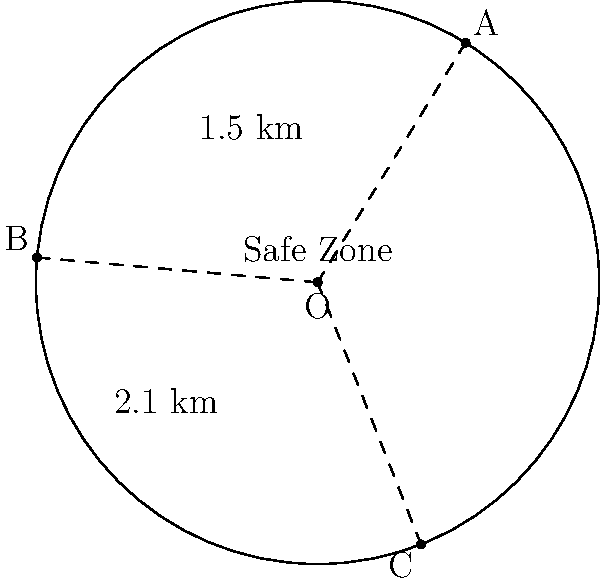A circular safe zone is established around a coal-fired power plant to minimize health risks. Three data points (A, B, and C) on the circumference of this safe zone are known. The distance between A and B is 1.5 km, and the distance between B and C is 2.1 km. What is the radius of the safe zone in kilometers? Let's solve this step-by-step:

1) In a circle, the center angle subtended by a chord is twice the inscribed angle subtended by the same chord.

2) The inscribed angle for chord AB is 45° (half of the 90° central angle AOB), and for BC is 45° (half of the 90° central angle BOC).

3) We can use the chord length formula: $chord = 2R \sin(\theta/2)$, where R is the radius and $\theta$ is the central angle.

4) For AB: $1.5 = 2R \sin(90°/2) = 2R \sin(45°) = 2R (\sqrt{2}/2)$

5) For BC: $2.1 = 2R \sin(90°/2) = 2R \sin(45°) = 2R (\sqrt{2}/2)$

6) From step 4: $R = 1.5 / (\sqrt{2}) = 1.5 / 1.414 = 1.061$ km

7) We can verify using step 5: $R = 2.1 / (\sqrt{2}) = 2.1 / 1.414 = 1.485$ km

8) The slight difference is due to rounding in the given measurements. We'll use the average:

   $R = (1.061 + 1.485) / 2 = 1.273$ km
Answer: 1.27 km 